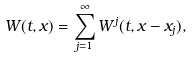<formula> <loc_0><loc_0><loc_500><loc_500>W ( t , x ) = \sum _ { j = 1 } ^ { \infty } W ^ { j } ( t , x - x _ { j } ) ,</formula> 